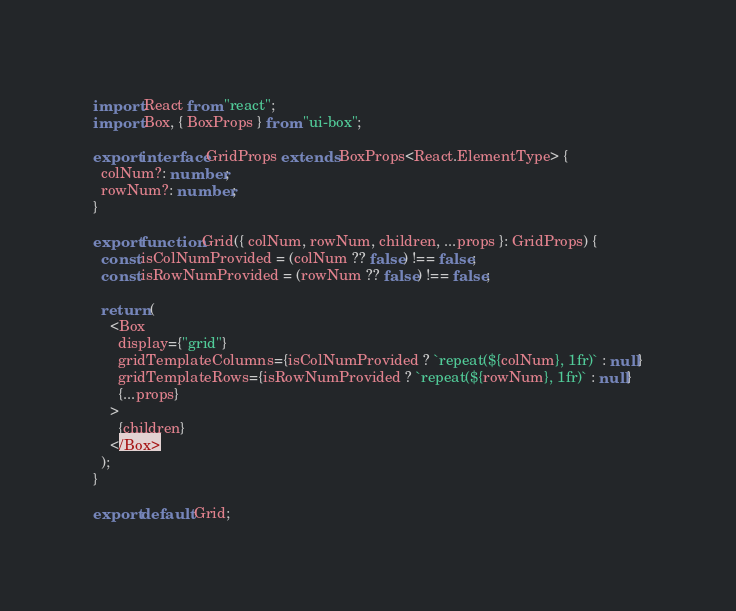Convert code to text. <code><loc_0><loc_0><loc_500><loc_500><_TypeScript_>import React from "react";
import Box, { BoxProps } from "ui-box";

export interface GridProps extends BoxProps<React.ElementType> {
  colNum?: number;
  rowNum?: number;
}

export function Grid({ colNum, rowNum, children, ...props }: GridProps) {
  const isColNumProvided = (colNum ?? false) !== false;
  const isRowNumProvided = (rowNum ?? false) !== false;

  return (
    <Box
      display={"grid"}
      gridTemplateColumns={isColNumProvided ? `repeat(${colNum}, 1fr)` : null}
      gridTemplateRows={isRowNumProvided ? `repeat(${rowNum}, 1fr)` : null}
      {...props}
    >
      {children}
    </Box>
  );
}

export default Grid;
</code> 